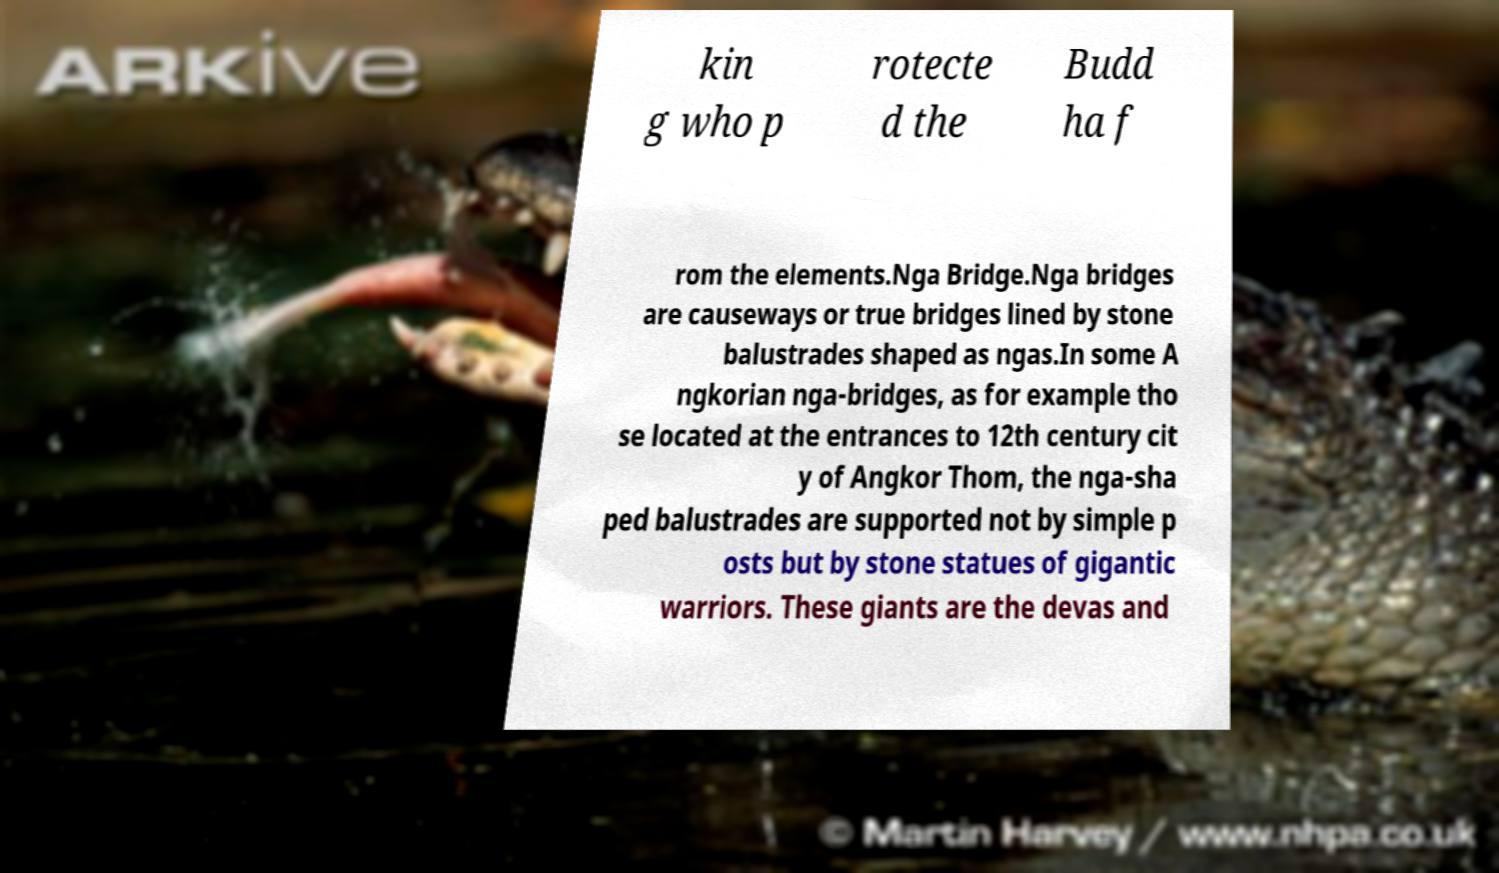Could you extract and type out the text from this image? kin g who p rotecte d the Budd ha f rom the elements.Nga Bridge.Nga bridges are causeways or true bridges lined by stone balustrades shaped as ngas.In some A ngkorian nga-bridges, as for example tho se located at the entrances to 12th century cit y of Angkor Thom, the nga-sha ped balustrades are supported not by simple p osts but by stone statues of gigantic warriors. These giants are the devas and 